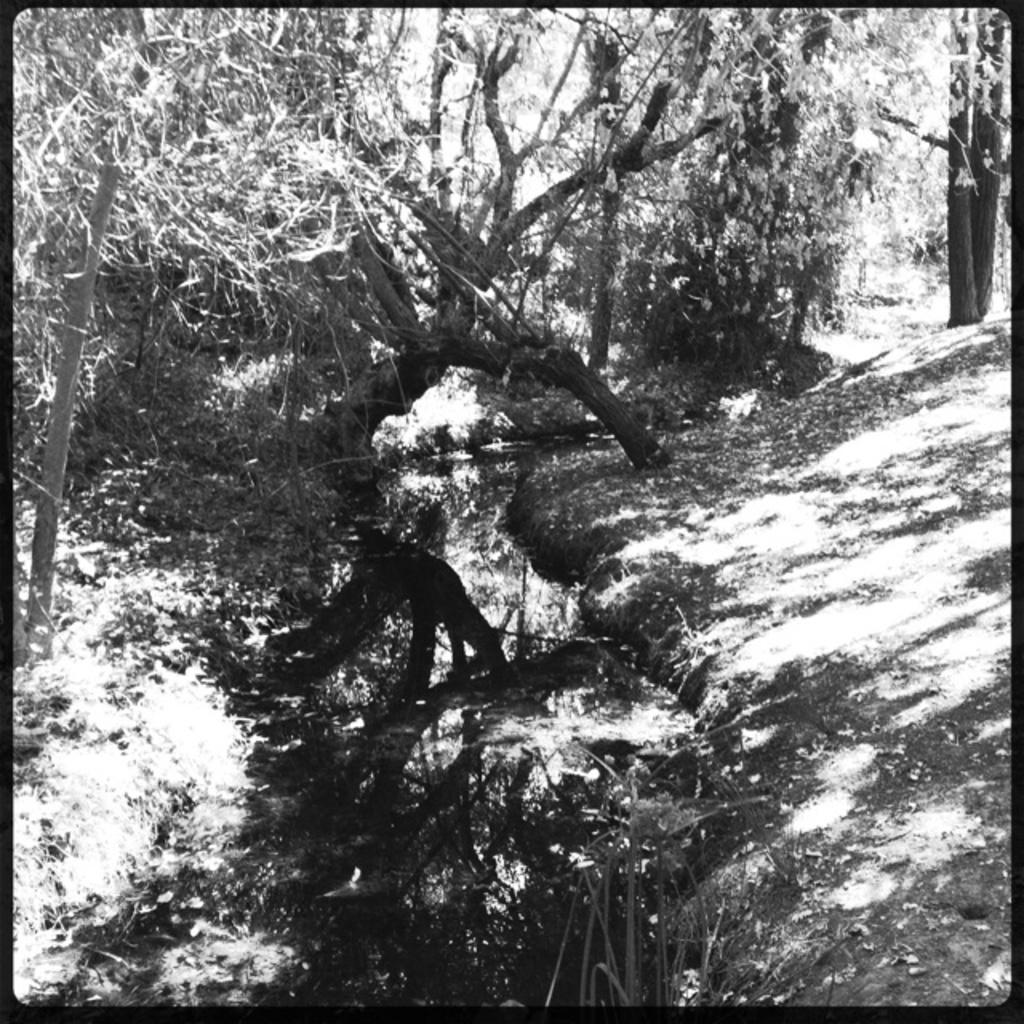What is the color scheme of the image? The image is black and white. Has the image been altered in any way? Yes, the image has been edited. What type of environment is depicted in the image? The scene resembles a forest. How many trees are visible in the image? There are many trees on the ground. What body of water can be seen at the bottom of the image? There is a lake at the bottom of the image. What type of milk is being poured into the lake in the image? There is no milk being poured into the lake in the image; it is a black and white image of a forest scene. Can you see the heart of the forest in the image? There is no specific "heart" of the forest depicted in the image; it is a general forest scene with many trees and a lake. 